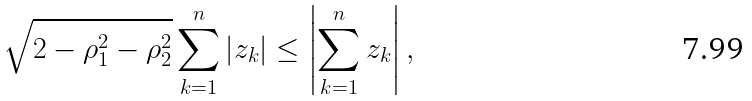<formula> <loc_0><loc_0><loc_500><loc_500>\sqrt { 2 - \rho _ { 1 } ^ { 2 } - \rho _ { 2 } ^ { 2 } } \sum _ { k = 1 } ^ { n } \left | z _ { k } \right | \leq \left | \sum _ { k = 1 } ^ { n } z _ { k } \right | ,</formula> 